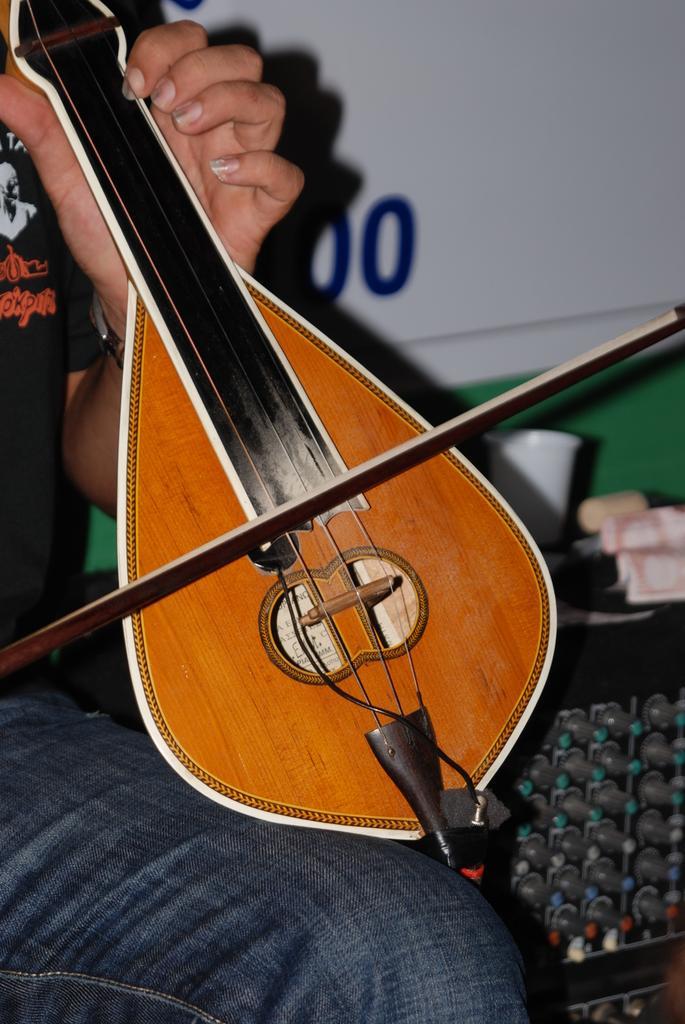In one or two sentences, can you explain what this image depicts? In the image it is a brown color violin a person wearing black color shirt is holding violin with his left hand and playing it with his right hand, in the background there is a white color wall. 